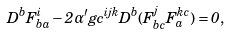<formula> <loc_0><loc_0><loc_500><loc_500>D ^ { b } F _ { b a } ^ { i } - 2 \alpha ^ { \prime } g c ^ { i j k } D ^ { b } ( F _ { b c } ^ { j } F _ { a } ^ { k c } ) = 0 ,</formula> 